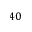Convert formula to latex. <formula><loc_0><loc_0><loc_500><loc_500>4 0</formula> 